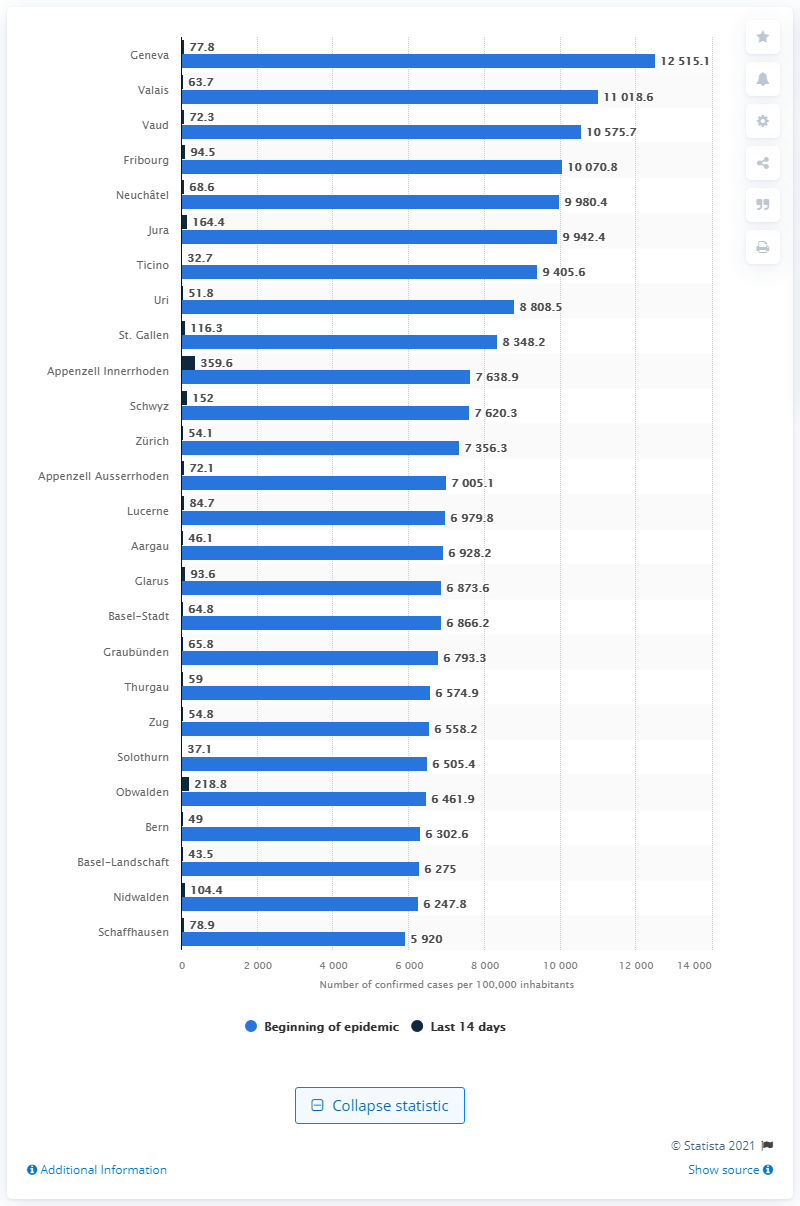Highlight a few significant elements in this photo. Geneva had the highest infection rate per 100,000 inhabitants among all the cities. 